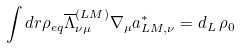<formula> <loc_0><loc_0><loc_500><loc_500>\int d { r } { \rho _ { e q } } \overline { \Lambda } _ { \nu \mu } ^ { ( L M ) } \nabla _ { \mu } a ^ { \ast } _ { L M , \nu } = d _ { L } \, \rho _ { 0 }</formula> 